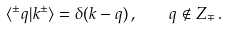Convert formula to latex. <formula><loc_0><loc_0><loc_500><loc_500>\langle ^ { \pm } q | k ^ { \pm } \rangle = \delta ( k - q ) \, , \quad q \notin Z _ { \mp } \, .</formula> 